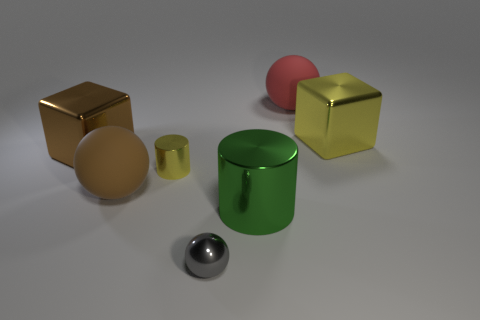Add 1 green cylinders. How many objects exist? 8 Subtract all brown rubber spheres. How many spheres are left? 2 Subtract all blocks. How many objects are left? 5 Add 6 big yellow things. How many big yellow things exist? 7 Subtract all red spheres. How many spheres are left? 2 Subtract 0 cyan spheres. How many objects are left? 7 Subtract 1 cylinders. How many cylinders are left? 1 Subtract all green cylinders. Subtract all green cubes. How many cylinders are left? 1 Subtract all tiny cyan shiny spheres. Subtract all matte spheres. How many objects are left? 5 Add 6 small yellow shiny cylinders. How many small yellow shiny cylinders are left? 7 